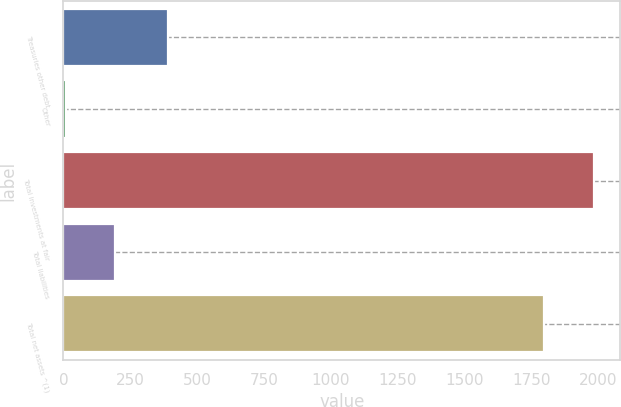<chart> <loc_0><loc_0><loc_500><loc_500><bar_chart><fcel>Treasuries other debt<fcel>Other<fcel>Total investments at fair<fcel>Total liabilities<fcel>Total net assets ^(1)<nl><fcel>390<fcel>8<fcel>1983<fcel>192<fcel>1799<nl></chart> 